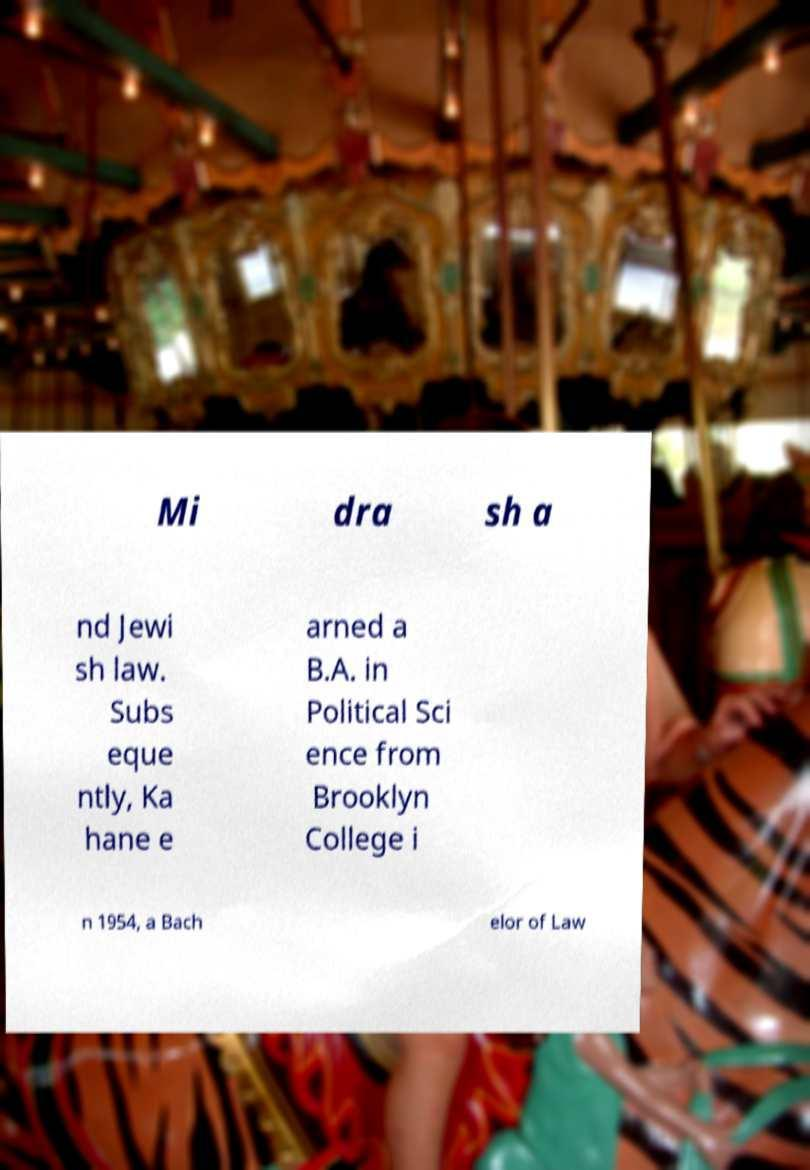Could you assist in decoding the text presented in this image and type it out clearly? Mi dra sh a nd Jewi sh law. Subs eque ntly, Ka hane e arned a B.A. in Political Sci ence from Brooklyn College i n 1954, a Bach elor of Law 